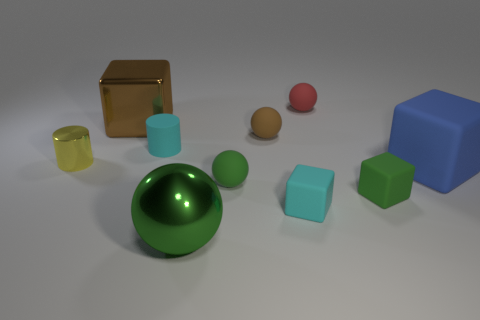What size is the metal object that is right of the yellow object and behind the large ball?
Give a very brief answer. Large. What number of other things are there of the same material as the small green ball
Keep it short and to the point. 6. What size is the block left of the green metallic ball?
Your answer should be compact. Large. What number of tiny things are either green rubber objects or metal cylinders?
Keep it short and to the point. 3. Are there any other things that are the same color as the metal ball?
Offer a very short reply. Yes. There is a tiny red thing; are there any matte things left of it?
Make the answer very short. Yes. There is a metal object that is on the right side of the big metal thing that is behind the big blue matte object; what is its size?
Provide a short and direct response. Large. Are there the same number of brown things on the left side of the yellow metal thing and big cubes right of the tiny matte cylinder?
Your answer should be very brief. No. Are there any tiny objects to the left of the large shiny thing that is to the right of the brown metal object?
Provide a succinct answer. Yes. There is a sphere right of the brown rubber thing that is right of the brown metallic thing; what number of tiny metallic objects are on the left side of it?
Keep it short and to the point. 1. 